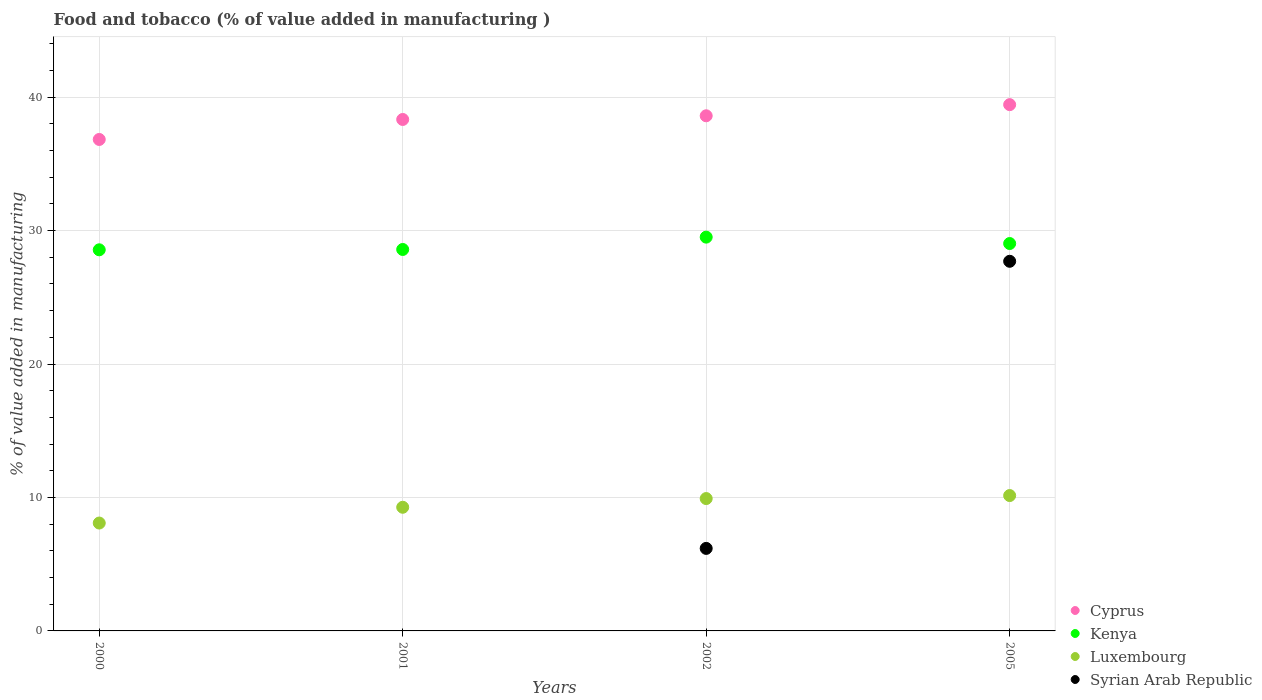What is the value added in manufacturing food and tobacco in Cyprus in 2005?
Offer a very short reply. 39.43. Across all years, what is the maximum value added in manufacturing food and tobacco in Syrian Arab Republic?
Provide a succinct answer. 27.7. Across all years, what is the minimum value added in manufacturing food and tobacco in Syrian Arab Republic?
Keep it short and to the point. 0. In which year was the value added in manufacturing food and tobacco in Luxembourg maximum?
Give a very brief answer. 2005. What is the total value added in manufacturing food and tobacco in Luxembourg in the graph?
Your answer should be compact. 37.41. What is the difference between the value added in manufacturing food and tobacco in Kenya in 2001 and that in 2002?
Provide a succinct answer. -0.92. What is the difference between the value added in manufacturing food and tobacco in Cyprus in 2005 and the value added in manufacturing food and tobacco in Syrian Arab Republic in 2001?
Offer a terse response. 39.43. What is the average value added in manufacturing food and tobacco in Syrian Arab Republic per year?
Make the answer very short. 8.47. In the year 2002, what is the difference between the value added in manufacturing food and tobacco in Syrian Arab Republic and value added in manufacturing food and tobacco in Luxembourg?
Make the answer very short. -3.73. What is the ratio of the value added in manufacturing food and tobacco in Cyprus in 2000 to that in 2001?
Provide a succinct answer. 0.96. Is the value added in manufacturing food and tobacco in Kenya in 2001 less than that in 2005?
Offer a very short reply. Yes. Is the difference between the value added in manufacturing food and tobacco in Syrian Arab Republic in 2002 and 2005 greater than the difference between the value added in manufacturing food and tobacco in Luxembourg in 2002 and 2005?
Keep it short and to the point. No. What is the difference between the highest and the second highest value added in manufacturing food and tobacco in Kenya?
Your answer should be very brief. 0.48. What is the difference between the highest and the lowest value added in manufacturing food and tobacco in Syrian Arab Republic?
Keep it short and to the point. 27.7. In how many years, is the value added in manufacturing food and tobacco in Luxembourg greater than the average value added in manufacturing food and tobacco in Luxembourg taken over all years?
Your answer should be compact. 2. Is the sum of the value added in manufacturing food and tobacco in Luxembourg in 2000 and 2005 greater than the maximum value added in manufacturing food and tobacco in Syrian Arab Republic across all years?
Offer a terse response. No. Is it the case that in every year, the sum of the value added in manufacturing food and tobacco in Cyprus and value added in manufacturing food and tobacco in Kenya  is greater than the sum of value added in manufacturing food and tobacco in Syrian Arab Republic and value added in manufacturing food and tobacco in Luxembourg?
Offer a terse response. Yes. Is it the case that in every year, the sum of the value added in manufacturing food and tobacco in Cyprus and value added in manufacturing food and tobacco in Luxembourg  is greater than the value added in manufacturing food and tobacco in Kenya?
Give a very brief answer. Yes. Does the value added in manufacturing food and tobacco in Cyprus monotonically increase over the years?
Offer a terse response. Yes. How many dotlines are there?
Keep it short and to the point. 4. Are the values on the major ticks of Y-axis written in scientific E-notation?
Offer a very short reply. No. Where does the legend appear in the graph?
Provide a short and direct response. Bottom right. What is the title of the graph?
Keep it short and to the point. Food and tobacco (% of value added in manufacturing ). Does "New Caledonia" appear as one of the legend labels in the graph?
Provide a succinct answer. No. What is the label or title of the Y-axis?
Your answer should be compact. % of value added in manufacturing. What is the % of value added in manufacturing in Cyprus in 2000?
Your response must be concise. 36.82. What is the % of value added in manufacturing of Kenya in 2000?
Your answer should be very brief. 28.56. What is the % of value added in manufacturing in Luxembourg in 2000?
Give a very brief answer. 8.08. What is the % of value added in manufacturing of Syrian Arab Republic in 2000?
Keep it short and to the point. 0. What is the % of value added in manufacturing of Cyprus in 2001?
Give a very brief answer. 38.32. What is the % of value added in manufacturing of Kenya in 2001?
Give a very brief answer. 28.58. What is the % of value added in manufacturing of Luxembourg in 2001?
Offer a very short reply. 9.27. What is the % of value added in manufacturing in Syrian Arab Republic in 2001?
Give a very brief answer. 0. What is the % of value added in manufacturing of Cyprus in 2002?
Make the answer very short. 38.6. What is the % of value added in manufacturing of Kenya in 2002?
Provide a short and direct response. 29.51. What is the % of value added in manufacturing of Luxembourg in 2002?
Keep it short and to the point. 9.92. What is the % of value added in manufacturing in Syrian Arab Republic in 2002?
Offer a terse response. 6.18. What is the % of value added in manufacturing of Cyprus in 2005?
Provide a succinct answer. 39.43. What is the % of value added in manufacturing of Kenya in 2005?
Make the answer very short. 29.03. What is the % of value added in manufacturing of Luxembourg in 2005?
Provide a succinct answer. 10.14. What is the % of value added in manufacturing in Syrian Arab Republic in 2005?
Make the answer very short. 27.7. Across all years, what is the maximum % of value added in manufacturing of Cyprus?
Your response must be concise. 39.43. Across all years, what is the maximum % of value added in manufacturing of Kenya?
Ensure brevity in your answer.  29.51. Across all years, what is the maximum % of value added in manufacturing of Luxembourg?
Ensure brevity in your answer.  10.14. Across all years, what is the maximum % of value added in manufacturing in Syrian Arab Republic?
Provide a succinct answer. 27.7. Across all years, what is the minimum % of value added in manufacturing of Cyprus?
Offer a terse response. 36.82. Across all years, what is the minimum % of value added in manufacturing in Kenya?
Offer a very short reply. 28.56. Across all years, what is the minimum % of value added in manufacturing in Luxembourg?
Your response must be concise. 8.08. What is the total % of value added in manufacturing in Cyprus in the graph?
Ensure brevity in your answer.  153.18. What is the total % of value added in manufacturing of Kenya in the graph?
Keep it short and to the point. 115.67. What is the total % of value added in manufacturing in Luxembourg in the graph?
Your answer should be very brief. 37.41. What is the total % of value added in manufacturing of Syrian Arab Republic in the graph?
Offer a terse response. 33.88. What is the difference between the % of value added in manufacturing of Cyprus in 2000 and that in 2001?
Offer a very short reply. -1.5. What is the difference between the % of value added in manufacturing in Kenya in 2000 and that in 2001?
Offer a very short reply. -0.03. What is the difference between the % of value added in manufacturing of Luxembourg in 2000 and that in 2001?
Offer a very short reply. -1.18. What is the difference between the % of value added in manufacturing of Cyprus in 2000 and that in 2002?
Make the answer very short. -1.77. What is the difference between the % of value added in manufacturing in Kenya in 2000 and that in 2002?
Your answer should be very brief. -0.95. What is the difference between the % of value added in manufacturing of Luxembourg in 2000 and that in 2002?
Provide a short and direct response. -1.83. What is the difference between the % of value added in manufacturing of Cyprus in 2000 and that in 2005?
Your answer should be compact. -2.61. What is the difference between the % of value added in manufacturing in Kenya in 2000 and that in 2005?
Ensure brevity in your answer.  -0.47. What is the difference between the % of value added in manufacturing of Luxembourg in 2000 and that in 2005?
Your answer should be compact. -2.06. What is the difference between the % of value added in manufacturing in Cyprus in 2001 and that in 2002?
Offer a terse response. -0.28. What is the difference between the % of value added in manufacturing of Kenya in 2001 and that in 2002?
Your answer should be compact. -0.92. What is the difference between the % of value added in manufacturing of Luxembourg in 2001 and that in 2002?
Your answer should be very brief. -0.65. What is the difference between the % of value added in manufacturing of Cyprus in 2001 and that in 2005?
Your answer should be compact. -1.11. What is the difference between the % of value added in manufacturing in Kenya in 2001 and that in 2005?
Provide a short and direct response. -0.45. What is the difference between the % of value added in manufacturing of Luxembourg in 2001 and that in 2005?
Your answer should be compact. -0.88. What is the difference between the % of value added in manufacturing in Cyprus in 2002 and that in 2005?
Your response must be concise. -0.83. What is the difference between the % of value added in manufacturing in Kenya in 2002 and that in 2005?
Provide a succinct answer. 0.48. What is the difference between the % of value added in manufacturing in Luxembourg in 2002 and that in 2005?
Ensure brevity in your answer.  -0.22. What is the difference between the % of value added in manufacturing of Syrian Arab Republic in 2002 and that in 2005?
Offer a very short reply. -21.51. What is the difference between the % of value added in manufacturing in Cyprus in 2000 and the % of value added in manufacturing in Kenya in 2001?
Keep it short and to the point. 8.24. What is the difference between the % of value added in manufacturing of Cyprus in 2000 and the % of value added in manufacturing of Luxembourg in 2001?
Offer a very short reply. 27.56. What is the difference between the % of value added in manufacturing in Kenya in 2000 and the % of value added in manufacturing in Luxembourg in 2001?
Offer a very short reply. 19.29. What is the difference between the % of value added in manufacturing of Cyprus in 2000 and the % of value added in manufacturing of Kenya in 2002?
Provide a short and direct response. 7.32. What is the difference between the % of value added in manufacturing in Cyprus in 2000 and the % of value added in manufacturing in Luxembourg in 2002?
Provide a succinct answer. 26.91. What is the difference between the % of value added in manufacturing in Cyprus in 2000 and the % of value added in manufacturing in Syrian Arab Republic in 2002?
Offer a terse response. 30.64. What is the difference between the % of value added in manufacturing in Kenya in 2000 and the % of value added in manufacturing in Luxembourg in 2002?
Your answer should be compact. 18.64. What is the difference between the % of value added in manufacturing of Kenya in 2000 and the % of value added in manufacturing of Syrian Arab Republic in 2002?
Ensure brevity in your answer.  22.37. What is the difference between the % of value added in manufacturing of Luxembourg in 2000 and the % of value added in manufacturing of Syrian Arab Republic in 2002?
Make the answer very short. 1.9. What is the difference between the % of value added in manufacturing of Cyprus in 2000 and the % of value added in manufacturing of Kenya in 2005?
Make the answer very short. 7.8. What is the difference between the % of value added in manufacturing in Cyprus in 2000 and the % of value added in manufacturing in Luxembourg in 2005?
Provide a succinct answer. 26.68. What is the difference between the % of value added in manufacturing in Cyprus in 2000 and the % of value added in manufacturing in Syrian Arab Republic in 2005?
Offer a terse response. 9.13. What is the difference between the % of value added in manufacturing of Kenya in 2000 and the % of value added in manufacturing of Luxembourg in 2005?
Give a very brief answer. 18.41. What is the difference between the % of value added in manufacturing in Kenya in 2000 and the % of value added in manufacturing in Syrian Arab Republic in 2005?
Give a very brief answer. 0.86. What is the difference between the % of value added in manufacturing of Luxembourg in 2000 and the % of value added in manufacturing of Syrian Arab Republic in 2005?
Provide a succinct answer. -19.61. What is the difference between the % of value added in manufacturing of Cyprus in 2001 and the % of value added in manufacturing of Kenya in 2002?
Offer a terse response. 8.82. What is the difference between the % of value added in manufacturing of Cyprus in 2001 and the % of value added in manufacturing of Luxembourg in 2002?
Provide a short and direct response. 28.41. What is the difference between the % of value added in manufacturing of Cyprus in 2001 and the % of value added in manufacturing of Syrian Arab Republic in 2002?
Offer a terse response. 32.14. What is the difference between the % of value added in manufacturing of Kenya in 2001 and the % of value added in manufacturing of Luxembourg in 2002?
Keep it short and to the point. 18.66. What is the difference between the % of value added in manufacturing of Kenya in 2001 and the % of value added in manufacturing of Syrian Arab Republic in 2002?
Your answer should be very brief. 22.4. What is the difference between the % of value added in manufacturing of Luxembourg in 2001 and the % of value added in manufacturing of Syrian Arab Republic in 2002?
Provide a succinct answer. 3.08. What is the difference between the % of value added in manufacturing in Cyprus in 2001 and the % of value added in manufacturing in Kenya in 2005?
Keep it short and to the point. 9.3. What is the difference between the % of value added in manufacturing in Cyprus in 2001 and the % of value added in manufacturing in Luxembourg in 2005?
Provide a short and direct response. 28.18. What is the difference between the % of value added in manufacturing in Cyprus in 2001 and the % of value added in manufacturing in Syrian Arab Republic in 2005?
Provide a short and direct response. 10.63. What is the difference between the % of value added in manufacturing of Kenya in 2001 and the % of value added in manufacturing of Luxembourg in 2005?
Your answer should be compact. 18.44. What is the difference between the % of value added in manufacturing of Kenya in 2001 and the % of value added in manufacturing of Syrian Arab Republic in 2005?
Provide a short and direct response. 0.89. What is the difference between the % of value added in manufacturing of Luxembourg in 2001 and the % of value added in manufacturing of Syrian Arab Republic in 2005?
Ensure brevity in your answer.  -18.43. What is the difference between the % of value added in manufacturing in Cyprus in 2002 and the % of value added in manufacturing in Kenya in 2005?
Provide a short and direct response. 9.57. What is the difference between the % of value added in manufacturing of Cyprus in 2002 and the % of value added in manufacturing of Luxembourg in 2005?
Make the answer very short. 28.46. What is the difference between the % of value added in manufacturing of Cyprus in 2002 and the % of value added in manufacturing of Syrian Arab Republic in 2005?
Provide a short and direct response. 10.9. What is the difference between the % of value added in manufacturing in Kenya in 2002 and the % of value added in manufacturing in Luxembourg in 2005?
Your response must be concise. 19.36. What is the difference between the % of value added in manufacturing of Kenya in 2002 and the % of value added in manufacturing of Syrian Arab Republic in 2005?
Give a very brief answer. 1.81. What is the difference between the % of value added in manufacturing of Luxembourg in 2002 and the % of value added in manufacturing of Syrian Arab Republic in 2005?
Your answer should be very brief. -17.78. What is the average % of value added in manufacturing in Cyprus per year?
Give a very brief answer. 38.3. What is the average % of value added in manufacturing in Kenya per year?
Provide a succinct answer. 28.92. What is the average % of value added in manufacturing in Luxembourg per year?
Give a very brief answer. 9.35. What is the average % of value added in manufacturing of Syrian Arab Republic per year?
Ensure brevity in your answer.  8.47. In the year 2000, what is the difference between the % of value added in manufacturing in Cyprus and % of value added in manufacturing in Kenya?
Your answer should be very brief. 8.27. In the year 2000, what is the difference between the % of value added in manufacturing of Cyprus and % of value added in manufacturing of Luxembourg?
Give a very brief answer. 28.74. In the year 2000, what is the difference between the % of value added in manufacturing in Kenya and % of value added in manufacturing in Luxembourg?
Give a very brief answer. 20.47. In the year 2001, what is the difference between the % of value added in manufacturing in Cyprus and % of value added in manufacturing in Kenya?
Your response must be concise. 9.74. In the year 2001, what is the difference between the % of value added in manufacturing in Cyprus and % of value added in manufacturing in Luxembourg?
Your answer should be very brief. 29.06. In the year 2001, what is the difference between the % of value added in manufacturing in Kenya and % of value added in manufacturing in Luxembourg?
Your answer should be compact. 19.32. In the year 2002, what is the difference between the % of value added in manufacturing in Cyprus and % of value added in manufacturing in Kenya?
Provide a succinct answer. 9.09. In the year 2002, what is the difference between the % of value added in manufacturing of Cyprus and % of value added in manufacturing of Luxembourg?
Make the answer very short. 28.68. In the year 2002, what is the difference between the % of value added in manufacturing in Cyprus and % of value added in manufacturing in Syrian Arab Republic?
Provide a succinct answer. 32.42. In the year 2002, what is the difference between the % of value added in manufacturing of Kenya and % of value added in manufacturing of Luxembourg?
Provide a short and direct response. 19.59. In the year 2002, what is the difference between the % of value added in manufacturing of Kenya and % of value added in manufacturing of Syrian Arab Republic?
Offer a terse response. 23.32. In the year 2002, what is the difference between the % of value added in manufacturing in Luxembourg and % of value added in manufacturing in Syrian Arab Republic?
Your answer should be very brief. 3.73. In the year 2005, what is the difference between the % of value added in manufacturing of Cyprus and % of value added in manufacturing of Kenya?
Ensure brevity in your answer.  10.41. In the year 2005, what is the difference between the % of value added in manufacturing in Cyprus and % of value added in manufacturing in Luxembourg?
Ensure brevity in your answer.  29.29. In the year 2005, what is the difference between the % of value added in manufacturing of Cyprus and % of value added in manufacturing of Syrian Arab Republic?
Provide a succinct answer. 11.74. In the year 2005, what is the difference between the % of value added in manufacturing in Kenya and % of value added in manufacturing in Luxembourg?
Offer a terse response. 18.88. In the year 2005, what is the difference between the % of value added in manufacturing of Kenya and % of value added in manufacturing of Syrian Arab Republic?
Offer a very short reply. 1.33. In the year 2005, what is the difference between the % of value added in manufacturing of Luxembourg and % of value added in manufacturing of Syrian Arab Republic?
Your response must be concise. -17.55. What is the ratio of the % of value added in manufacturing in Cyprus in 2000 to that in 2001?
Your response must be concise. 0.96. What is the ratio of the % of value added in manufacturing of Luxembourg in 2000 to that in 2001?
Your answer should be compact. 0.87. What is the ratio of the % of value added in manufacturing in Cyprus in 2000 to that in 2002?
Give a very brief answer. 0.95. What is the ratio of the % of value added in manufacturing of Kenya in 2000 to that in 2002?
Your answer should be very brief. 0.97. What is the ratio of the % of value added in manufacturing in Luxembourg in 2000 to that in 2002?
Your response must be concise. 0.81. What is the ratio of the % of value added in manufacturing in Cyprus in 2000 to that in 2005?
Keep it short and to the point. 0.93. What is the ratio of the % of value added in manufacturing in Kenya in 2000 to that in 2005?
Keep it short and to the point. 0.98. What is the ratio of the % of value added in manufacturing in Luxembourg in 2000 to that in 2005?
Your response must be concise. 0.8. What is the ratio of the % of value added in manufacturing of Cyprus in 2001 to that in 2002?
Offer a very short reply. 0.99. What is the ratio of the % of value added in manufacturing in Kenya in 2001 to that in 2002?
Provide a short and direct response. 0.97. What is the ratio of the % of value added in manufacturing of Luxembourg in 2001 to that in 2002?
Provide a short and direct response. 0.93. What is the ratio of the % of value added in manufacturing in Cyprus in 2001 to that in 2005?
Provide a short and direct response. 0.97. What is the ratio of the % of value added in manufacturing of Kenya in 2001 to that in 2005?
Provide a short and direct response. 0.98. What is the ratio of the % of value added in manufacturing in Luxembourg in 2001 to that in 2005?
Ensure brevity in your answer.  0.91. What is the ratio of the % of value added in manufacturing in Cyprus in 2002 to that in 2005?
Give a very brief answer. 0.98. What is the ratio of the % of value added in manufacturing in Kenya in 2002 to that in 2005?
Offer a terse response. 1.02. What is the ratio of the % of value added in manufacturing of Luxembourg in 2002 to that in 2005?
Make the answer very short. 0.98. What is the ratio of the % of value added in manufacturing of Syrian Arab Republic in 2002 to that in 2005?
Give a very brief answer. 0.22. What is the difference between the highest and the second highest % of value added in manufacturing of Cyprus?
Ensure brevity in your answer.  0.83. What is the difference between the highest and the second highest % of value added in manufacturing of Kenya?
Provide a short and direct response. 0.48. What is the difference between the highest and the second highest % of value added in manufacturing of Luxembourg?
Offer a terse response. 0.22. What is the difference between the highest and the lowest % of value added in manufacturing of Cyprus?
Make the answer very short. 2.61. What is the difference between the highest and the lowest % of value added in manufacturing in Kenya?
Offer a very short reply. 0.95. What is the difference between the highest and the lowest % of value added in manufacturing of Luxembourg?
Offer a very short reply. 2.06. What is the difference between the highest and the lowest % of value added in manufacturing of Syrian Arab Republic?
Your answer should be very brief. 27.7. 